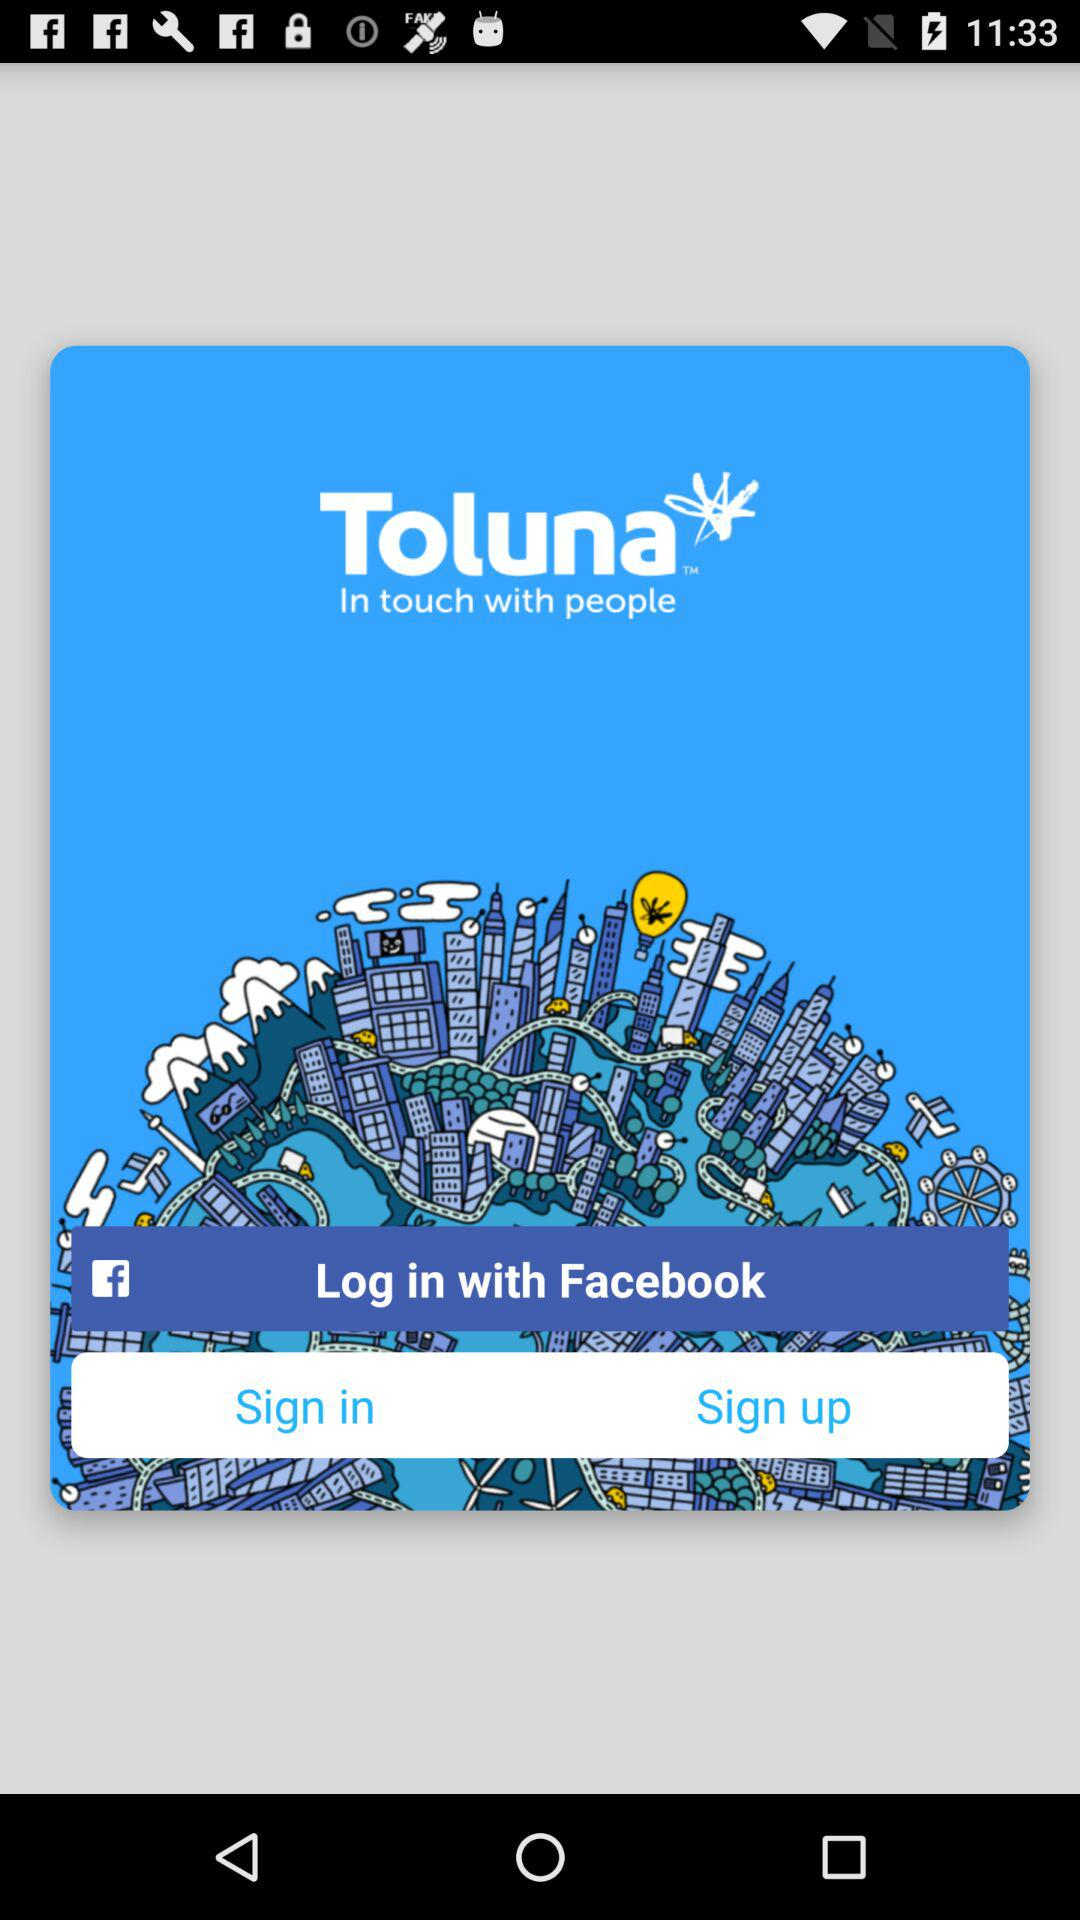What is the name of the application? The name of the application is "Toluna". 